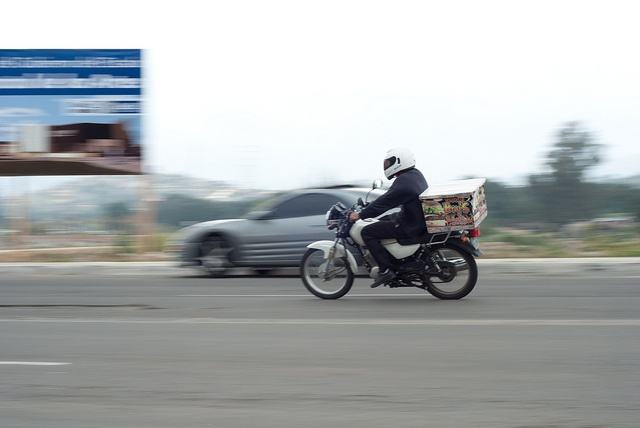Describe the objects in this image and their specific colors. I can see motorcycle in white, black, gray, darkgray, and lightgray tones, car in white, gray, darkgray, and black tones, and people in white, black, lightgray, and gray tones in this image. 